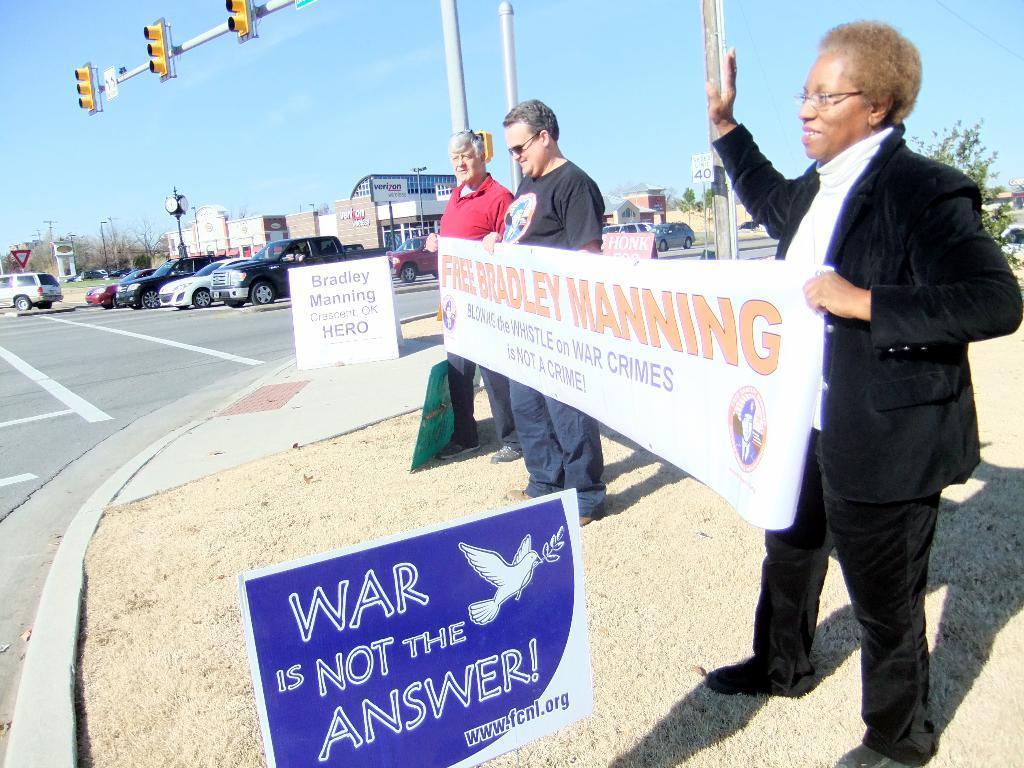Describe this image in one or two sentences. In this picture we can see there are three people holding a banner. In front of the people there is a board and behind the people there are some boards and poles with traffic signals and sign boards. There are some vehicles on the road and behind the vehicles there are buildings, trees and the sky. 